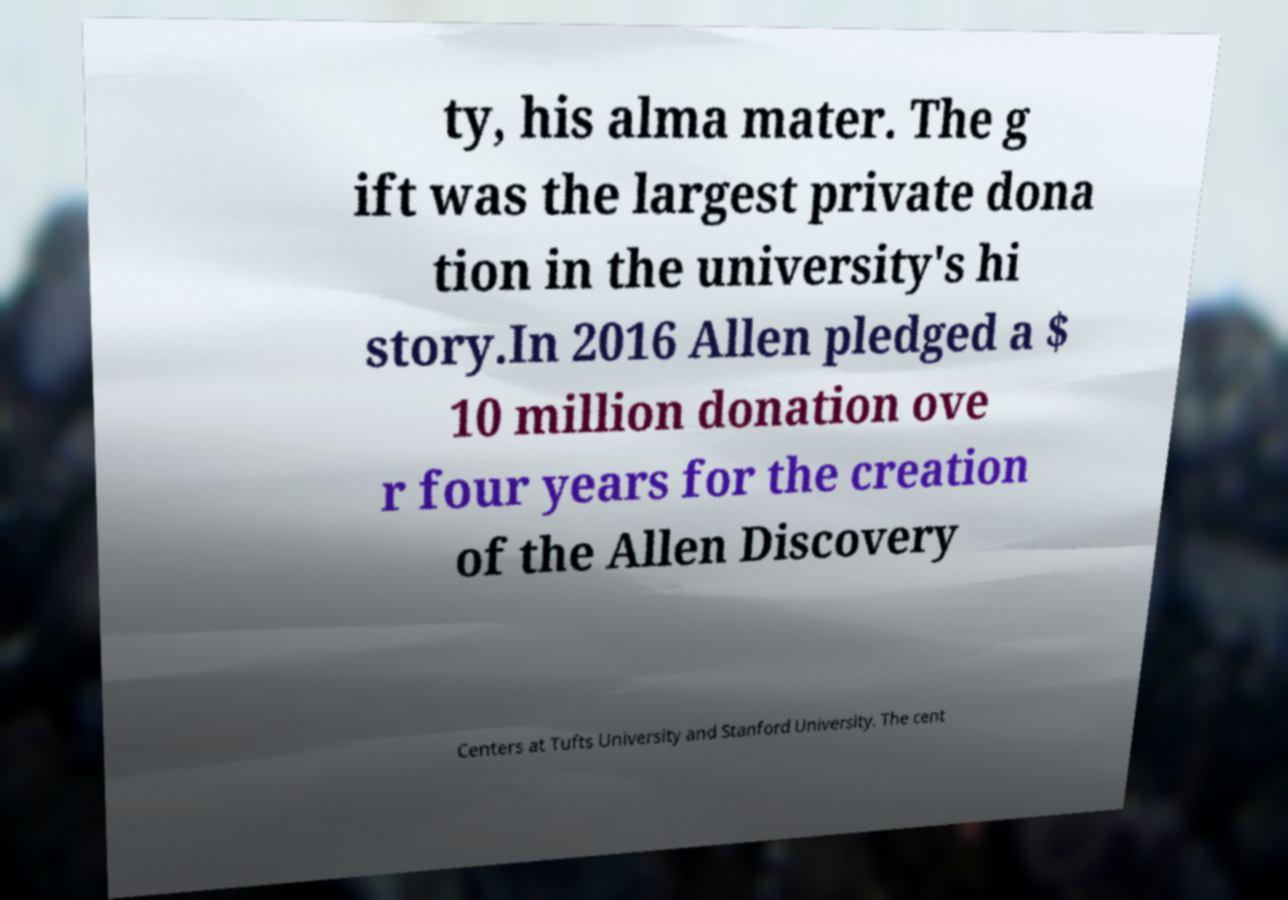For documentation purposes, I need the text within this image transcribed. Could you provide that? ty, his alma mater. The g ift was the largest private dona tion in the university's hi story.In 2016 Allen pledged a $ 10 million donation ove r four years for the creation of the Allen Discovery Centers at Tufts University and Stanford University. The cent 